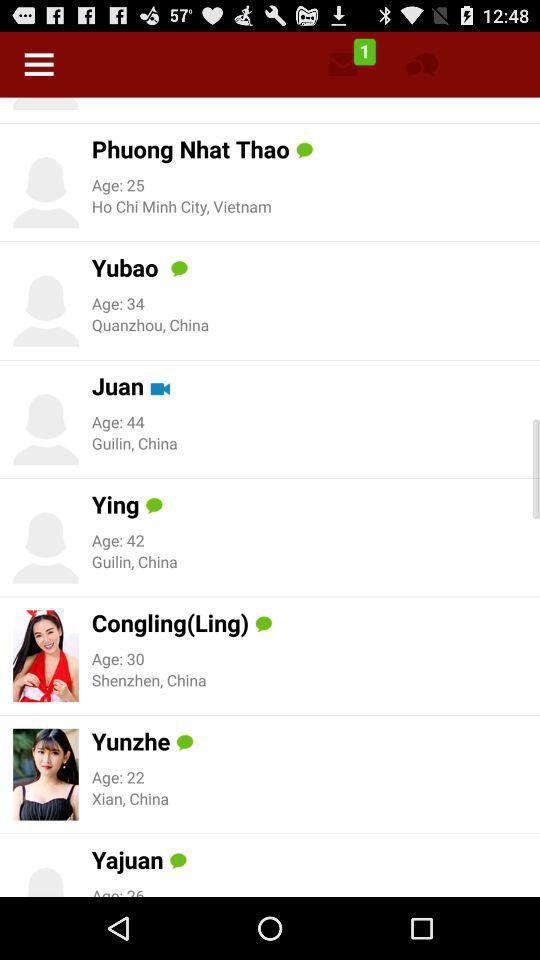What is the location of Juan? The location is "Guilin, China". 